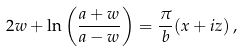<formula> <loc_0><loc_0><loc_500><loc_500>2 w + \ln \left ( \frac { a + w } { a - w } \right ) = \frac { \pi } { b } ( x + i z ) \, ,</formula> 